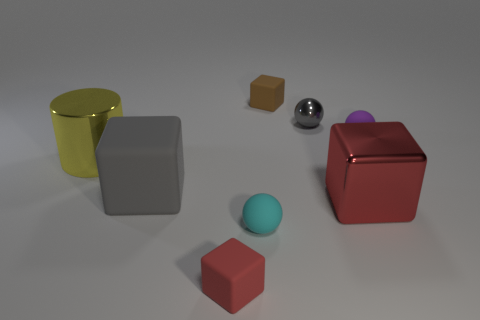Subtract all shiny blocks. How many blocks are left? 3 Subtract all cyan balls. How many red cubes are left? 2 Subtract 1 blocks. How many blocks are left? 3 Add 1 big brown rubber things. How many objects exist? 9 Subtract all brown blocks. How many blocks are left? 3 Subtract all spheres. How many objects are left? 5 Subtract all purple cylinders. Subtract all green spheres. How many cylinders are left? 1 Subtract all large cyan matte balls. Subtract all yellow objects. How many objects are left? 7 Add 6 large gray blocks. How many large gray blocks are left? 7 Add 1 tiny red rubber blocks. How many tiny red rubber blocks exist? 2 